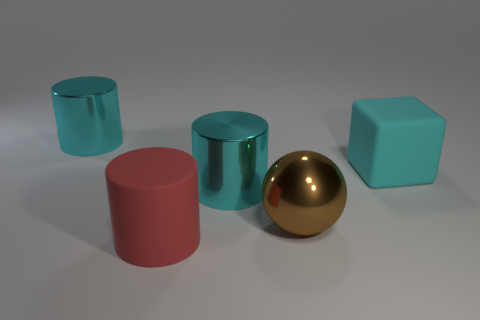Are there any brown balls that have the same material as the red cylinder?
Keep it short and to the point. No. Is the large cyan object in front of the large rubber block made of the same material as the large cylinder behind the big cyan block?
Your response must be concise. Yes. Are there an equal number of large red rubber cylinders that are behind the large rubber cube and large cylinders in front of the red matte cylinder?
Give a very brief answer. Yes. There is a cube that is the same size as the brown metallic thing; what is its color?
Make the answer very short. Cyan. Is there a big cylinder that has the same color as the cube?
Keep it short and to the point. Yes. How many objects are large things that are behind the brown metallic sphere or brown metal spheres?
Provide a succinct answer. 4. What number of other things are there of the same size as the sphere?
Make the answer very short. 4. There is a big cyan cylinder that is behind the cyan metal object right of the large cyan metal object that is behind the cyan matte thing; what is it made of?
Make the answer very short. Metal. How many spheres are either brown matte objects or red objects?
Give a very brief answer. 0. Are there any other things that are the same shape as the big brown object?
Offer a terse response. No. 